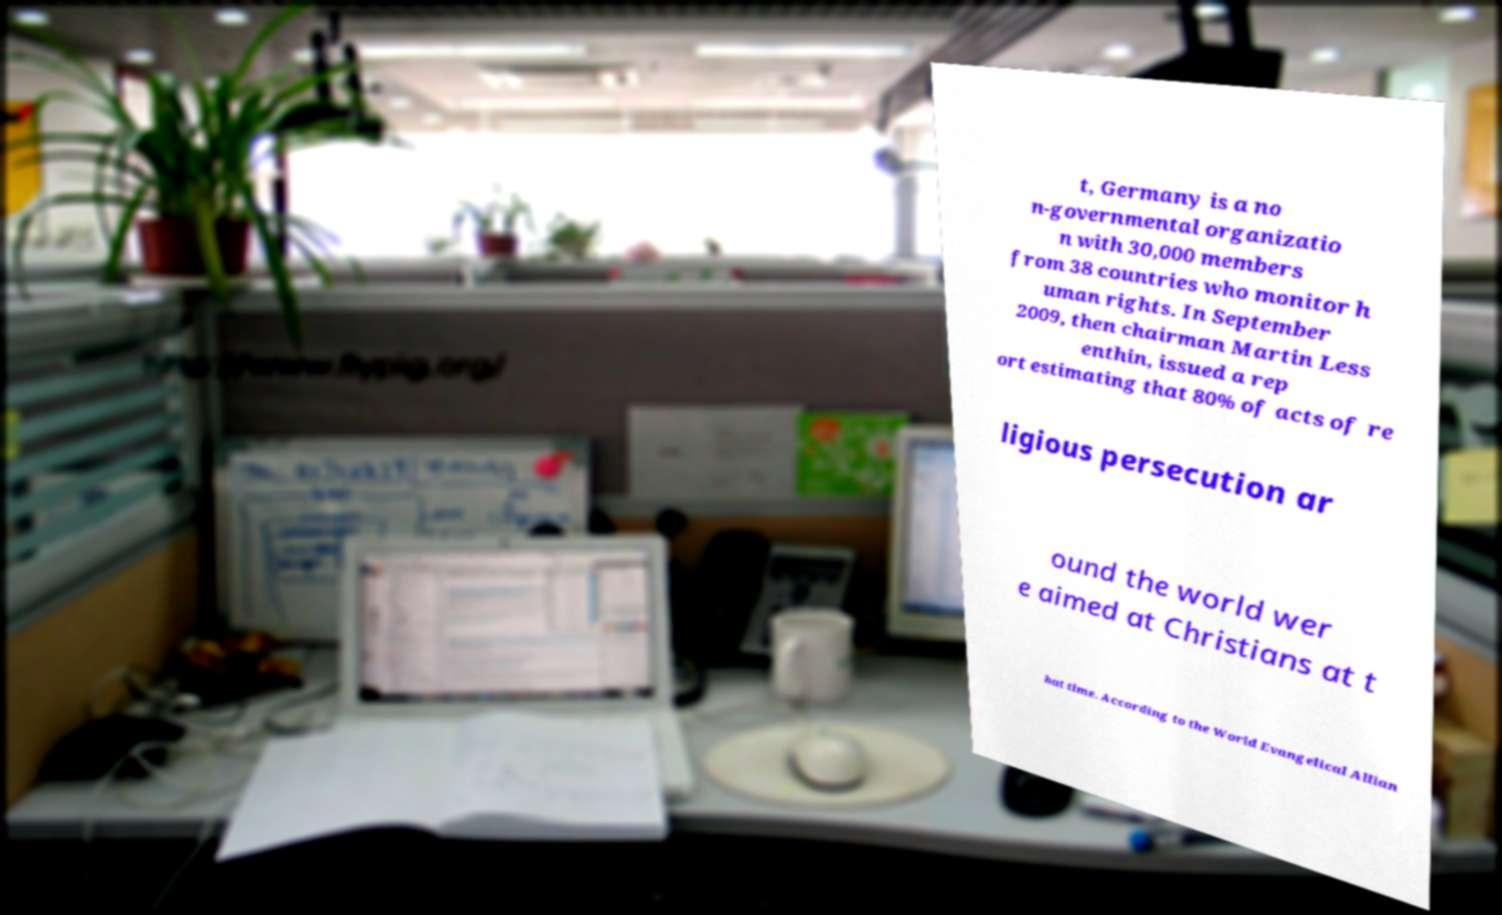Please read and relay the text visible in this image. What does it say? t, Germany is a no n-governmental organizatio n with 30,000 members from 38 countries who monitor h uman rights. In September 2009, then chairman Martin Less enthin, issued a rep ort estimating that 80% of acts of re ligious persecution ar ound the world wer e aimed at Christians at t hat time. According to the World Evangelical Allian 